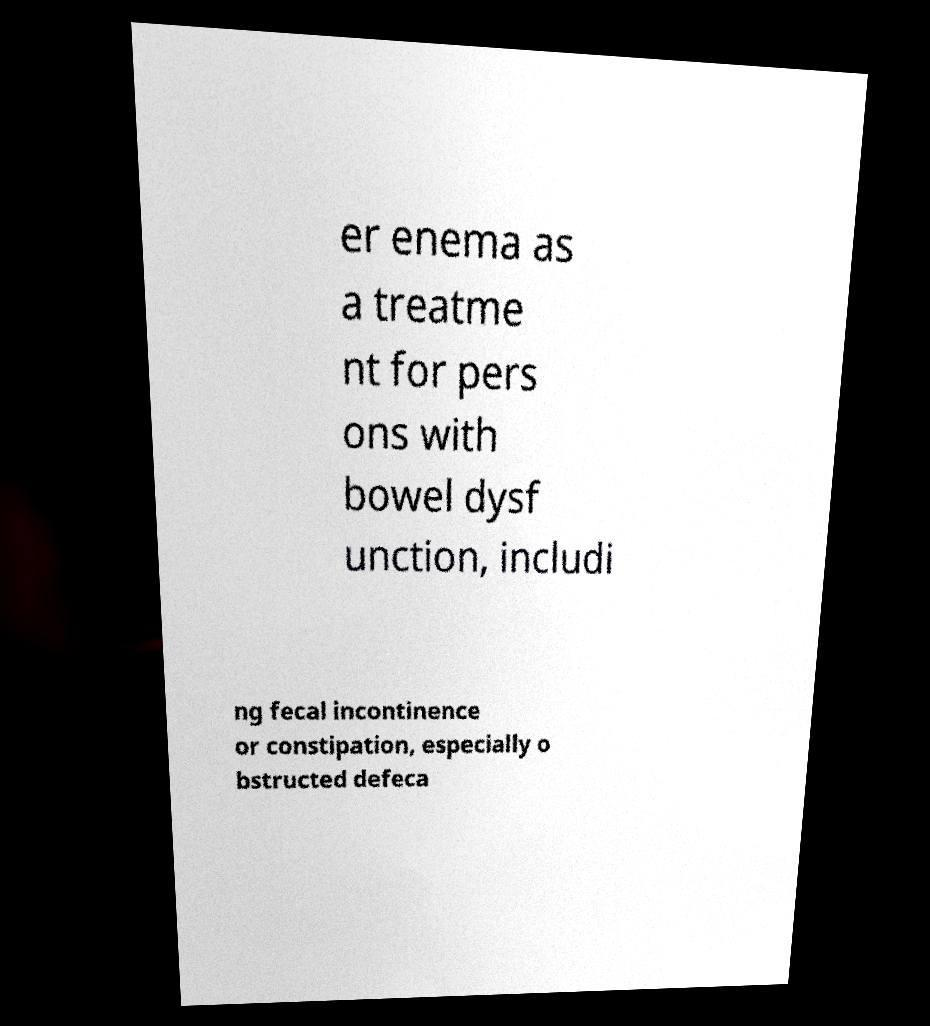I need the written content from this picture converted into text. Can you do that? er enema as a treatme nt for pers ons with bowel dysf unction, includi ng fecal incontinence or constipation, especially o bstructed defeca 